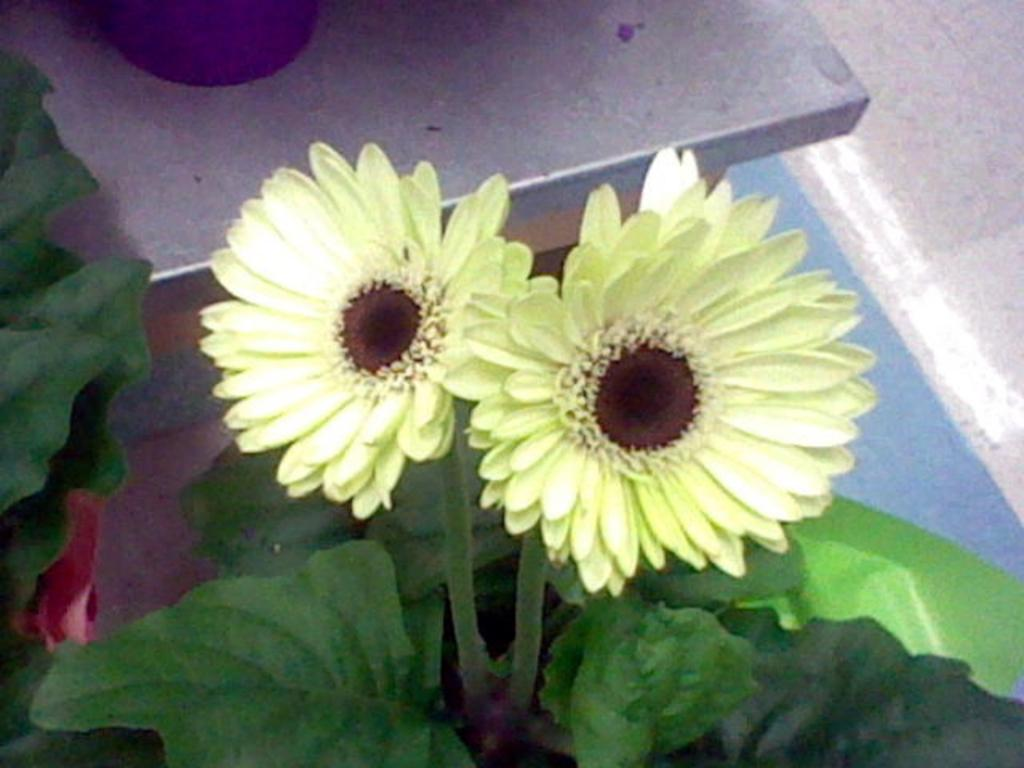What types of vegetation can be seen in the image? There are flowers and plants in the image. Where are the flowers and plants located in the image? The flowers and plants are in the middle of the image. What type of carpenter is working on the shape in the image? There is no carpenter or shape present in the image; it features flowers and plants. 